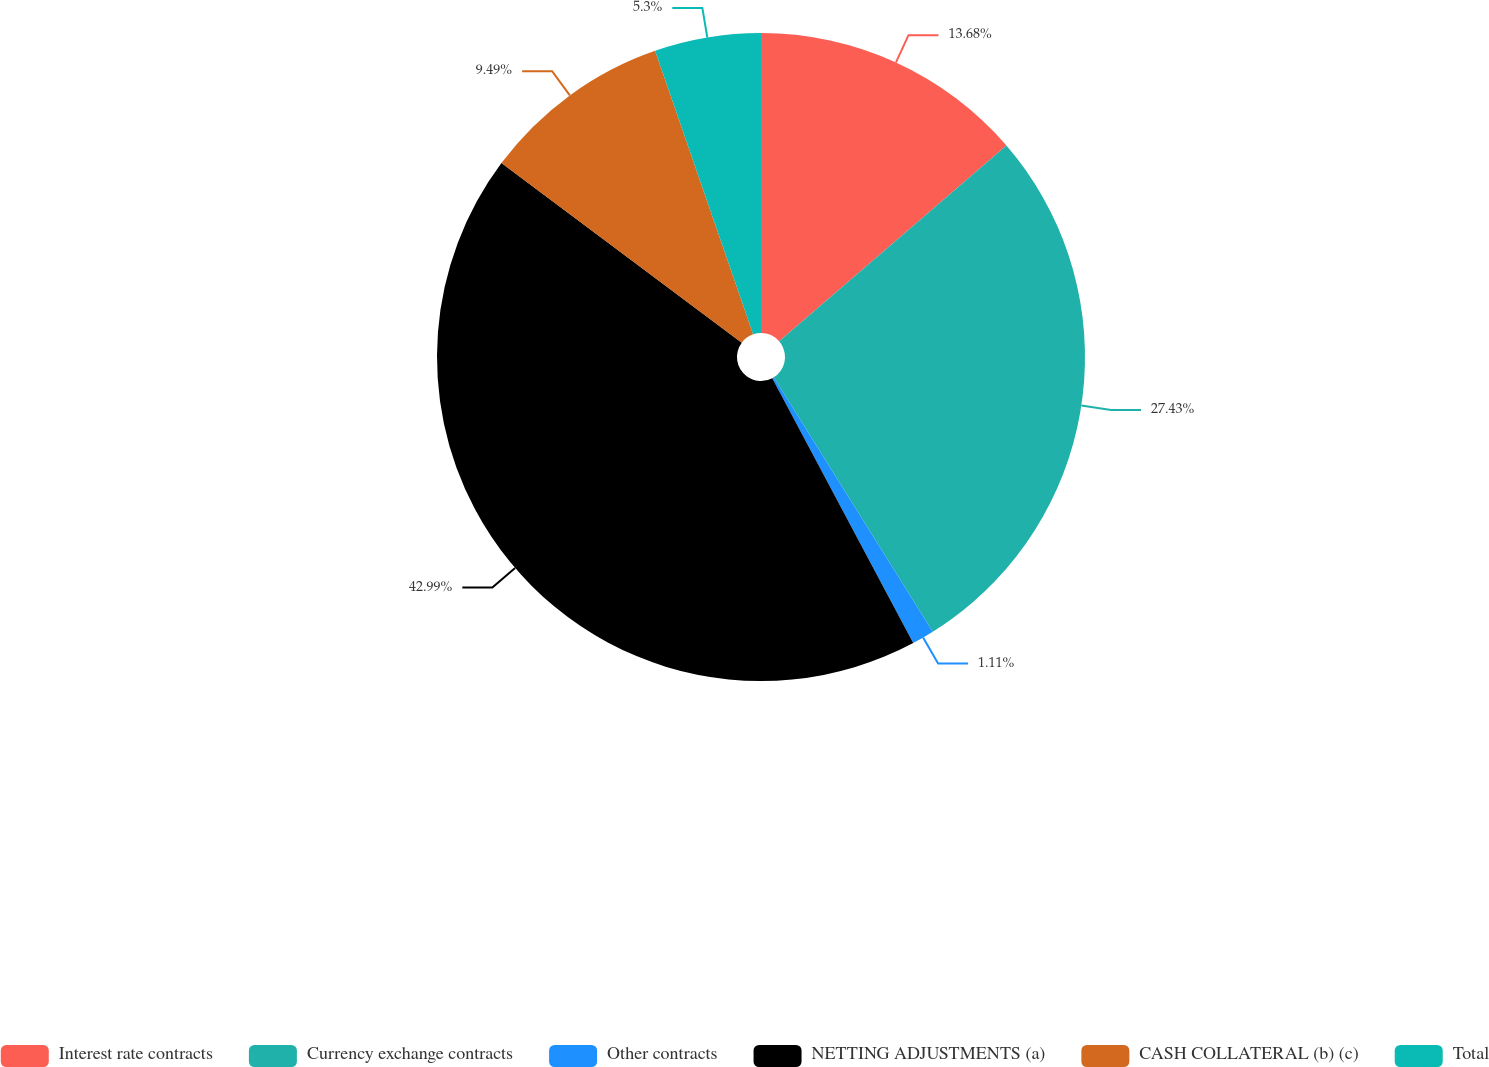Convert chart. <chart><loc_0><loc_0><loc_500><loc_500><pie_chart><fcel>Interest rate contracts<fcel>Currency exchange contracts<fcel>Other contracts<fcel>NETTING ADJUSTMENTS (a)<fcel>CASH COLLATERAL (b) (c)<fcel>Total<nl><fcel>13.68%<fcel>27.43%<fcel>1.11%<fcel>43.0%<fcel>9.49%<fcel>5.3%<nl></chart> 